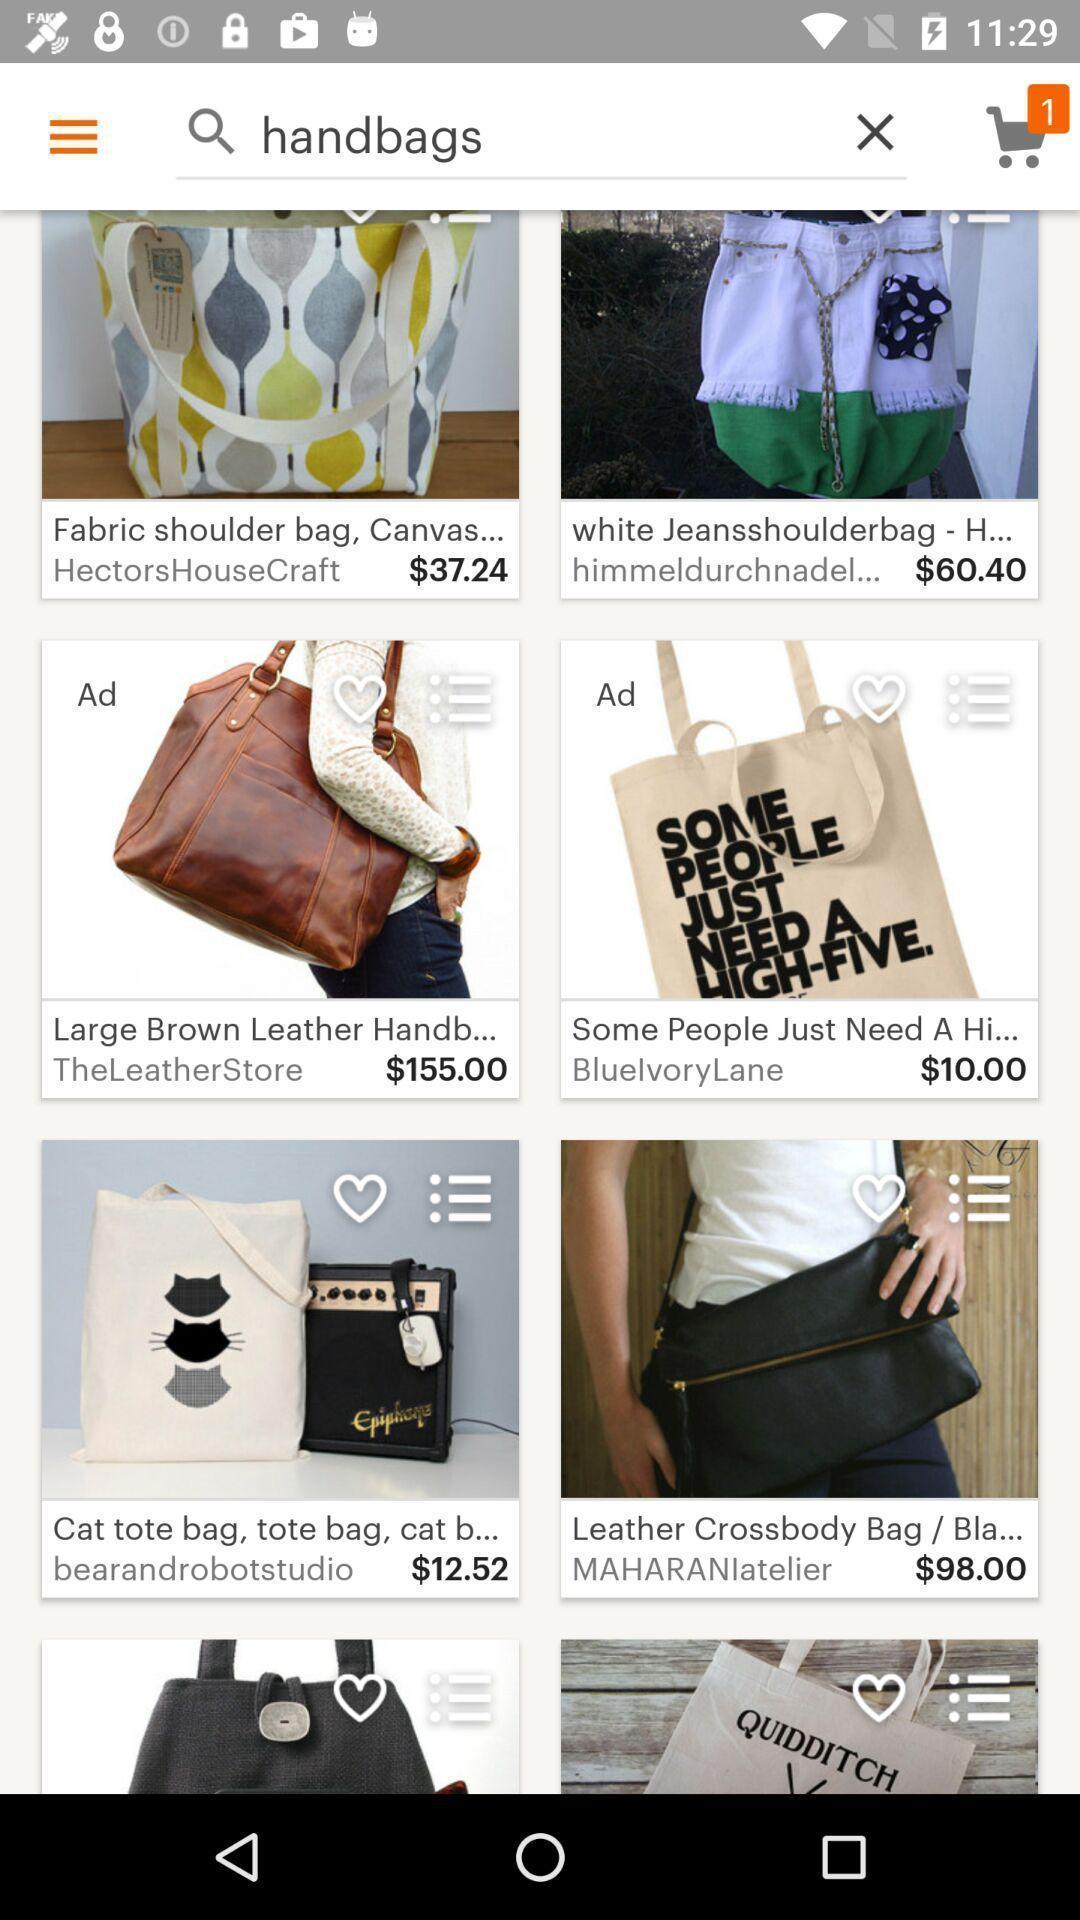Describe the visual elements of this screenshot. Search page of a shopping app. 